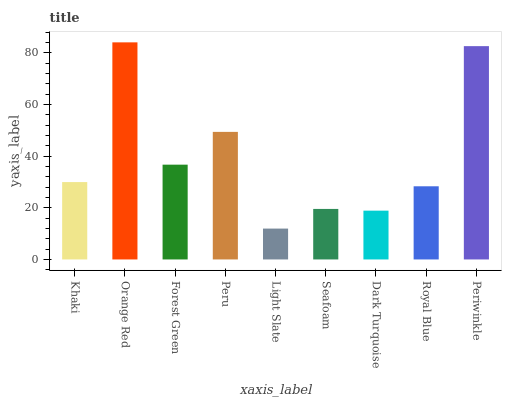Is Forest Green the minimum?
Answer yes or no. No. Is Forest Green the maximum?
Answer yes or no. No. Is Orange Red greater than Forest Green?
Answer yes or no. Yes. Is Forest Green less than Orange Red?
Answer yes or no. Yes. Is Forest Green greater than Orange Red?
Answer yes or no. No. Is Orange Red less than Forest Green?
Answer yes or no. No. Is Khaki the high median?
Answer yes or no. Yes. Is Khaki the low median?
Answer yes or no. Yes. Is Light Slate the high median?
Answer yes or no. No. Is Royal Blue the low median?
Answer yes or no. No. 